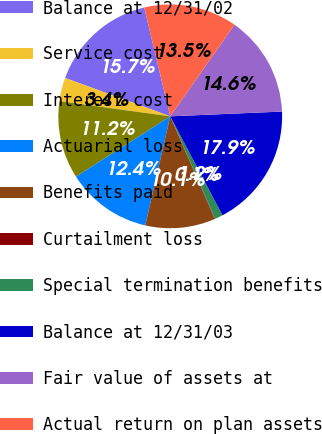<chart> <loc_0><loc_0><loc_500><loc_500><pie_chart><fcel>Balance at 12/31/02<fcel>Service cost<fcel>Interest cost<fcel>Actuarial loss<fcel>Benefits paid<fcel>Curtailment loss<fcel>Special termination benefits<fcel>Balance at 12/31/03<fcel>Fair value of assets at<fcel>Actual return on plan assets<nl><fcel>15.7%<fcel>3.4%<fcel>11.23%<fcel>12.35%<fcel>10.11%<fcel>0.05%<fcel>1.16%<fcel>17.94%<fcel>14.59%<fcel>13.47%<nl></chart> 